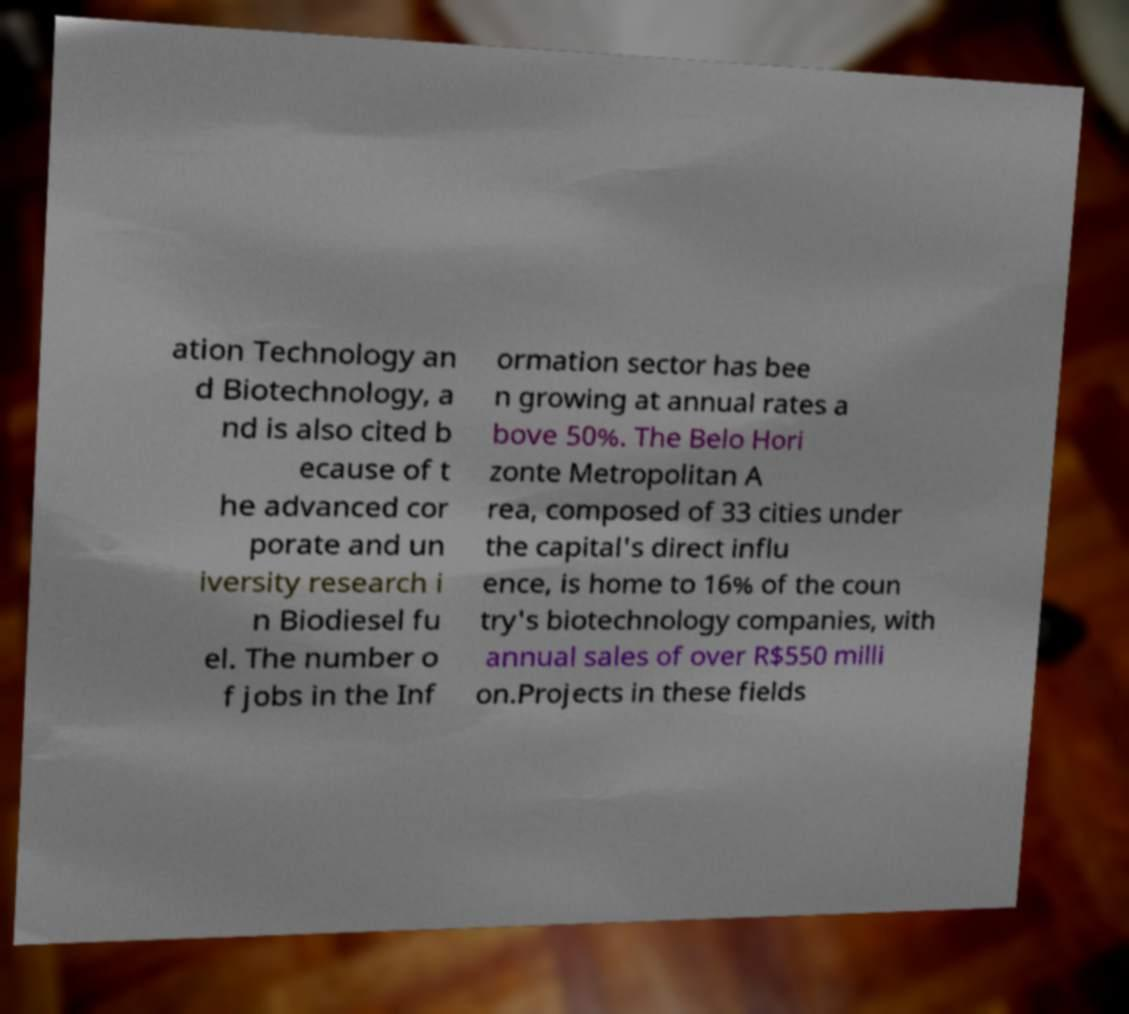Could you extract and type out the text from this image? ation Technology an d Biotechnology, a nd is also cited b ecause of t he advanced cor porate and un iversity research i n Biodiesel fu el. The number o f jobs in the Inf ormation sector has bee n growing at annual rates a bove 50%. The Belo Hori zonte Metropolitan A rea, composed of 33 cities under the capital's direct influ ence, is home to 16% of the coun try's biotechnology companies, with annual sales of over R$550 milli on.Projects in these fields 